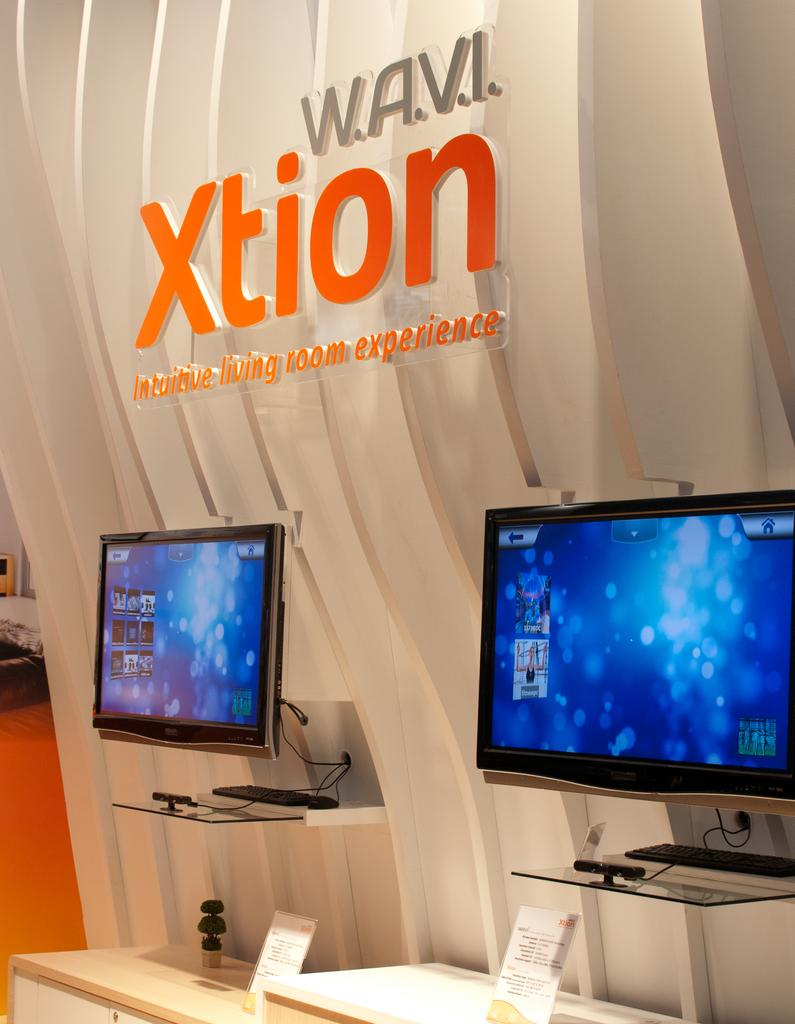<image>
Present a compact description of the photo's key features. Two computers monitors are set up on display under the sign W.A.V.I Xtion. 